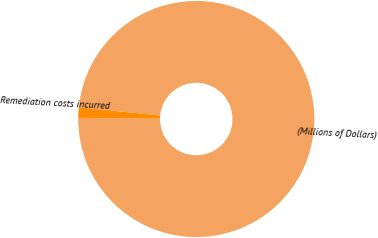Convert chart. <chart><loc_0><loc_0><loc_500><loc_500><pie_chart><fcel>(Millions of Dollars)<fcel>Remediation costs incurred<nl><fcel>98.58%<fcel>1.42%<nl></chart> 